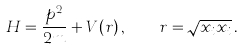<formula> <loc_0><loc_0><loc_500><loc_500>H = \frac { p ^ { 2 } } { 2 m } + V ( r ) \, , \quad r = \sqrt { x _ { i } x _ { i } } \, .</formula> 